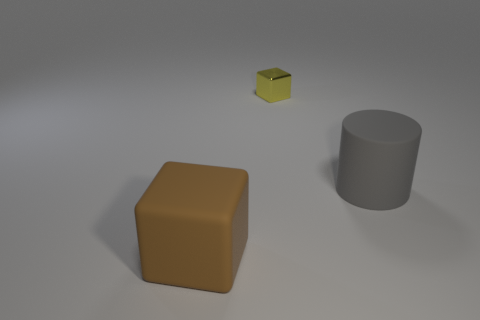Is the number of yellow shiny things that are on the left side of the tiny block greater than the number of matte cubes that are in front of the cylinder?
Keep it short and to the point. No. What is the material of the other object that is the same shape as the small thing?
Provide a short and direct response. Rubber. Are there any other things that are the same size as the gray object?
Provide a short and direct response. Yes. Is the color of the big thing that is in front of the large gray object the same as the object that is to the right of the tiny yellow metallic thing?
Give a very brief answer. No. There is a big gray matte object; what shape is it?
Offer a very short reply. Cylinder. Is the number of large gray cylinders in front of the small yellow thing greater than the number of small gray things?
Your answer should be very brief. Yes. What is the shape of the thing in front of the gray rubber cylinder?
Provide a short and direct response. Cube. How many other objects are the same shape as the gray rubber thing?
Offer a terse response. 0. Does the gray object that is behind the big brown matte block have the same material as the brown block?
Your answer should be compact. Yes. Are there an equal number of yellow things in front of the small yellow metal thing and large gray things that are to the right of the big brown matte thing?
Make the answer very short. No. 